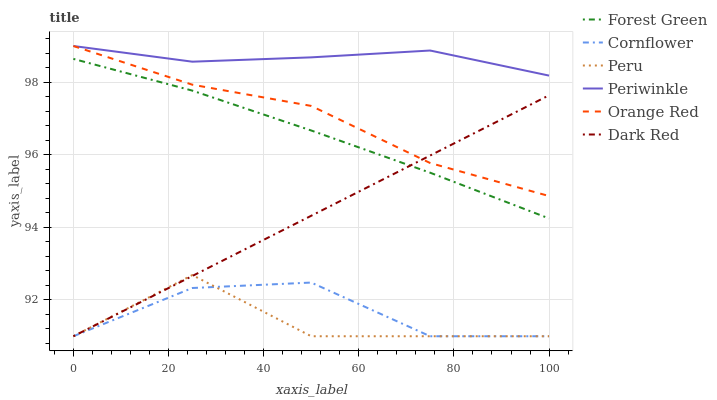Does Peru have the minimum area under the curve?
Answer yes or no. Yes. Does Periwinkle have the maximum area under the curve?
Answer yes or no. Yes. Does Dark Red have the minimum area under the curve?
Answer yes or no. No. Does Dark Red have the maximum area under the curve?
Answer yes or no. No. Is Dark Red the smoothest?
Answer yes or no. Yes. Is Peru the roughest?
Answer yes or no. Yes. Is Forest Green the smoothest?
Answer yes or no. No. Is Forest Green the roughest?
Answer yes or no. No. Does Cornflower have the lowest value?
Answer yes or no. Yes. Does Forest Green have the lowest value?
Answer yes or no. No. Does Orange Red have the highest value?
Answer yes or no. Yes. Does Dark Red have the highest value?
Answer yes or no. No. Is Cornflower less than Forest Green?
Answer yes or no. Yes. Is Periwinkle greater than Peru?
Answer yes or no. Yes. Does Cornflower intersect Peru?
Answer yes or no. Yes. Is Cornflower less than Peru?
Answer yes or no. No. Is Cornflower greater than Peru?
Answer yes or no. No. Does Cornflower intersect Forest Green?
Answer yes or no. No. 